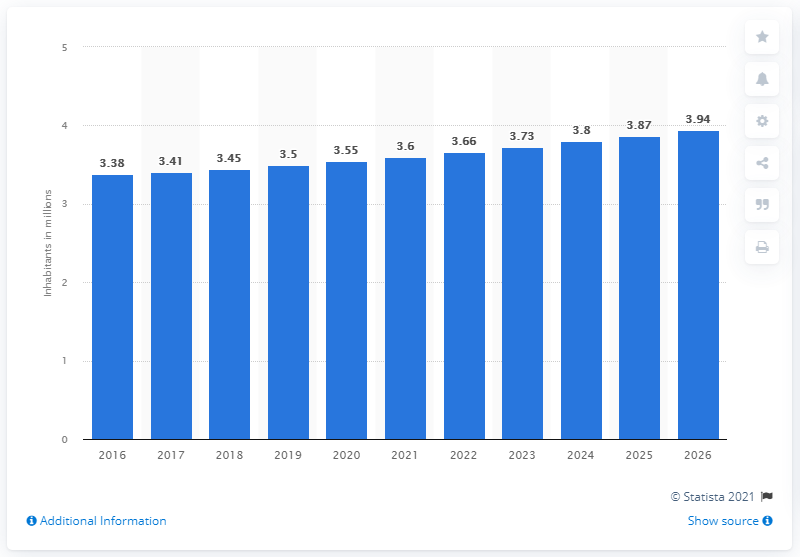Draw attention to some important aspects in this diagram. The population of Eritrea in 2019 was approximately 3.5 million people. 